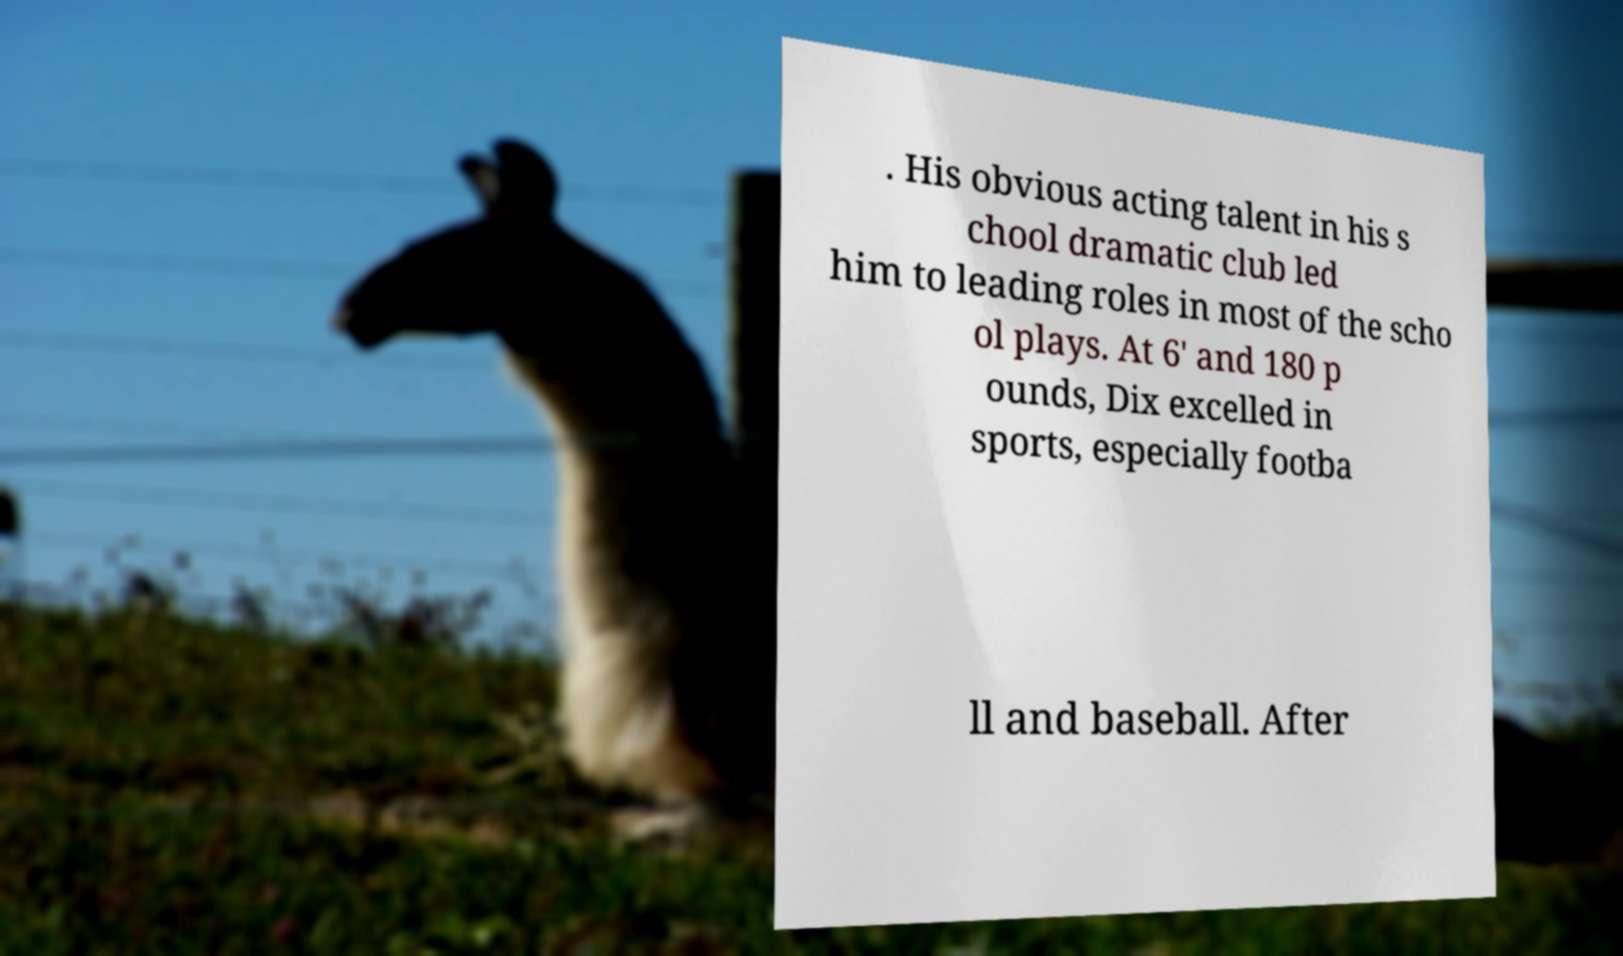Could you assist in decoding the text presented in this image and type it out clearly? . His obvious acting talent in his s chool dramatic club led him to leading roles in most of the scho ol plays. At 6' and 180 p ounds, Dix excelled in sports, especially footba ll and baseball. After 